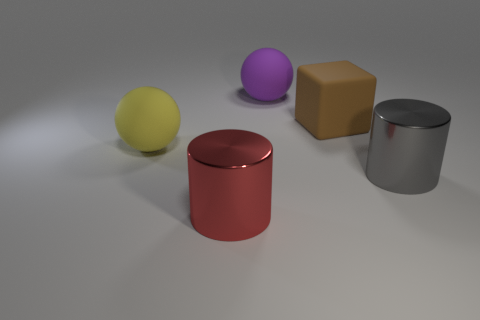Add 3 purple matte spheres. How many objects exist? 8 Subtract all spheres. How many objects are left? 3 Subtract all tiny brown shiny spheres. Subtract all spheres. How many objects are left? 3 Add 2 brown rubber blocks. How many brown rubber blocks are left? 3 Add 1 gray metallic cylinders. How many gray metallic cylinders exist? 2 Subtract 1 brown blocks. How many objects are left? 4 